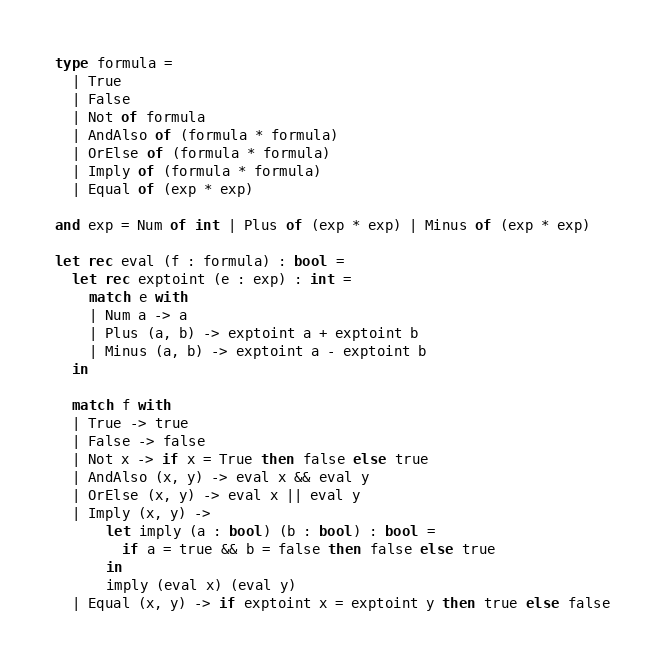<code> <loc_0><loc_0><loc_500><loc_500><_OCaml_>type formula =
  | True
  | False
  | Not of formula
  | AndAlso of (formula * formula)
  | OrElse of (formula * formula)
  | Imply of (formula * formula)
  | Equal of (exp * exp)

and exp = Num of int | Plus of (exp * exp) | Minus of (exp * exp)

let rec eval (f : formula) : bool =
  let rec exptoint (e : exp) : int =
    match e with
    | Num a -> a
    | Plus (a, b) -> exptoint a + exptoint b
    | Minus (a, b) -> exptoint a - exptoint b
  in

  match f with
  | True -> true
  | False -> false
  | Not x -> if x = True then false else true
  | AndAlso (x, y) -> eval x && eval y
  | OrElse (x, y) -> eval x || eval y
  | Imply (x, y) ->
      let imply (a : bool) (b : bool) : bool =
        if a = true && b = false then false else true
      in
      imply (eval x) (eval y)
  | Equal (x, y) -> if exptoint x = exptoint y then true else false
</code> 